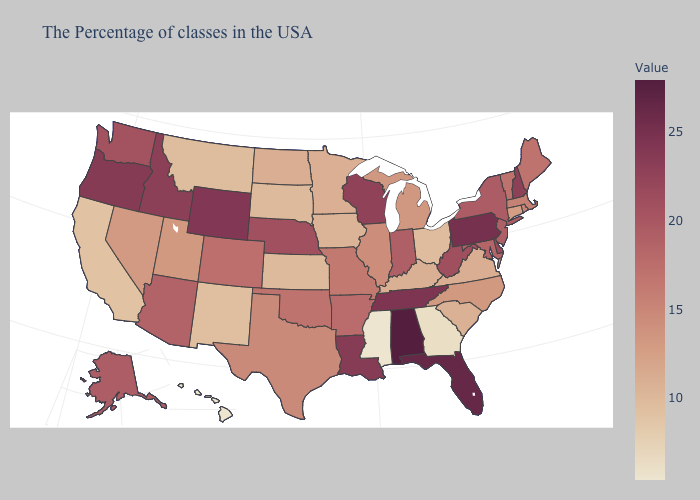Does Idaho have a lower value than Nevada?
Answer briefly. No. Does New Mexico have a lower value than Illinois?
Answer briefly. Yes. Is the legend a continuous bar?
Short answer required. Yes. 